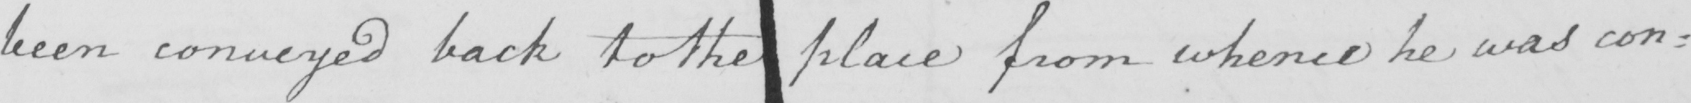Can you read and transcribe this handwriting? been conveyed back to the place from whence he was co : 